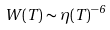Convert formula to latex. <formula><loc_0><loc_0><loc_500><loc_500>W ( T ) \sim \eta ( T ) ^ { - 6 }</formula> 